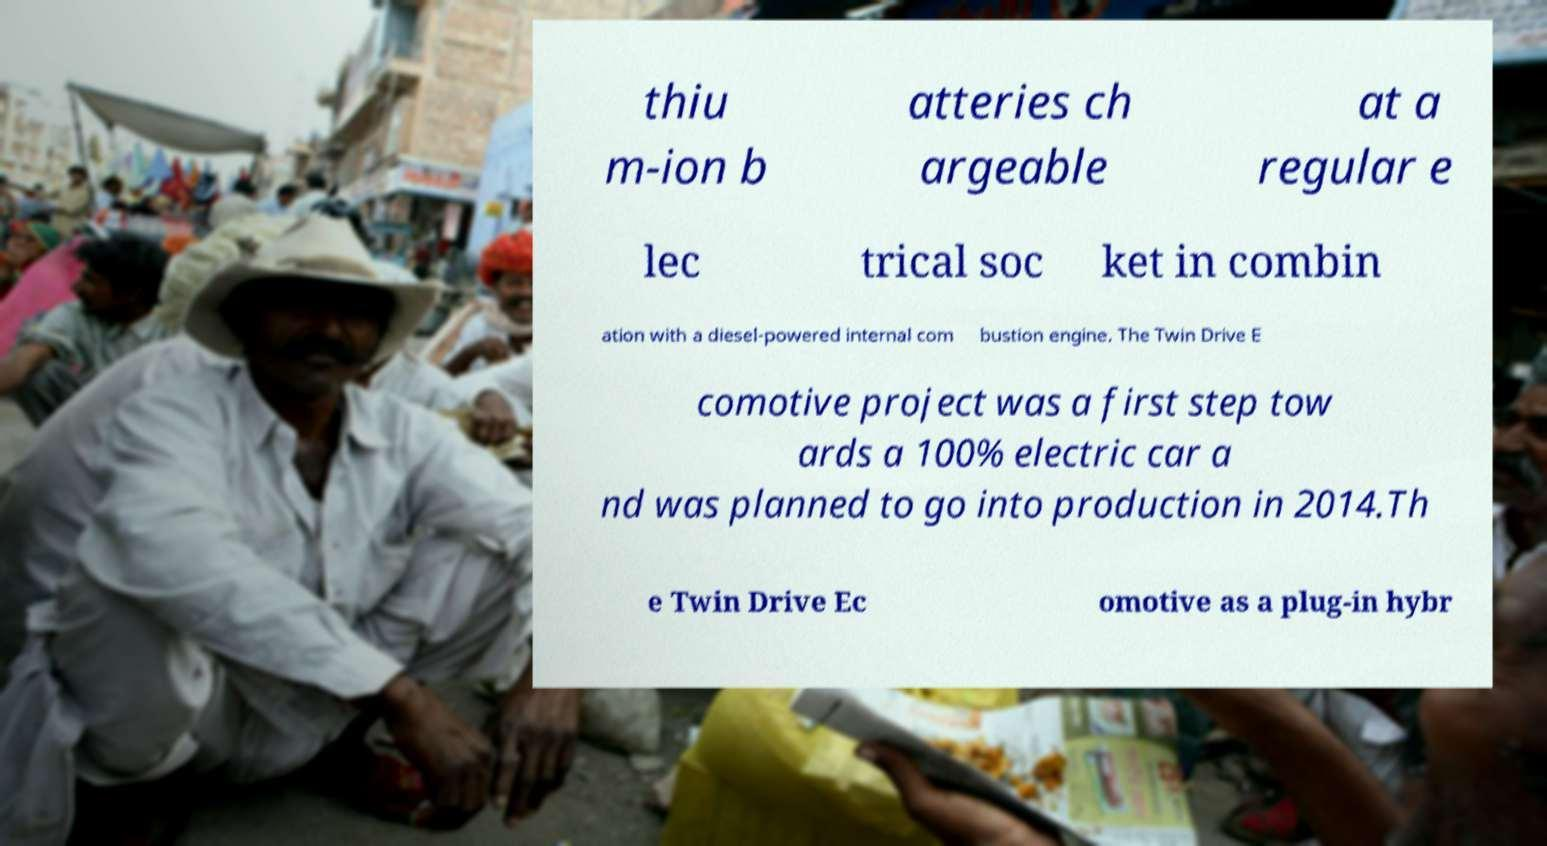Can you read and provide the text displayed in the image?This photo seems to have some interesting text. Can you extract and type it out for me? thiu m-ion b atteries ch argeable at a regular e lec trical soc ket in combin ation with a diesel-powered internal com bustion engine. The Twin Drive E comotive project was a first step tow ards a 100% electric car a nd was planned to go into production in 2014.Th e Twin Drive Ec omotive as a plug-in hybr 